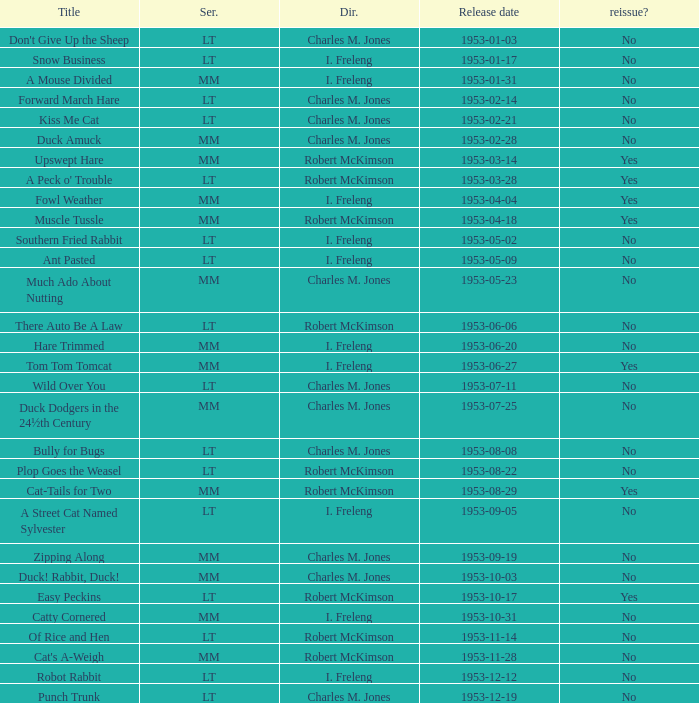What's the series of Kiss Me Cat? LT. 